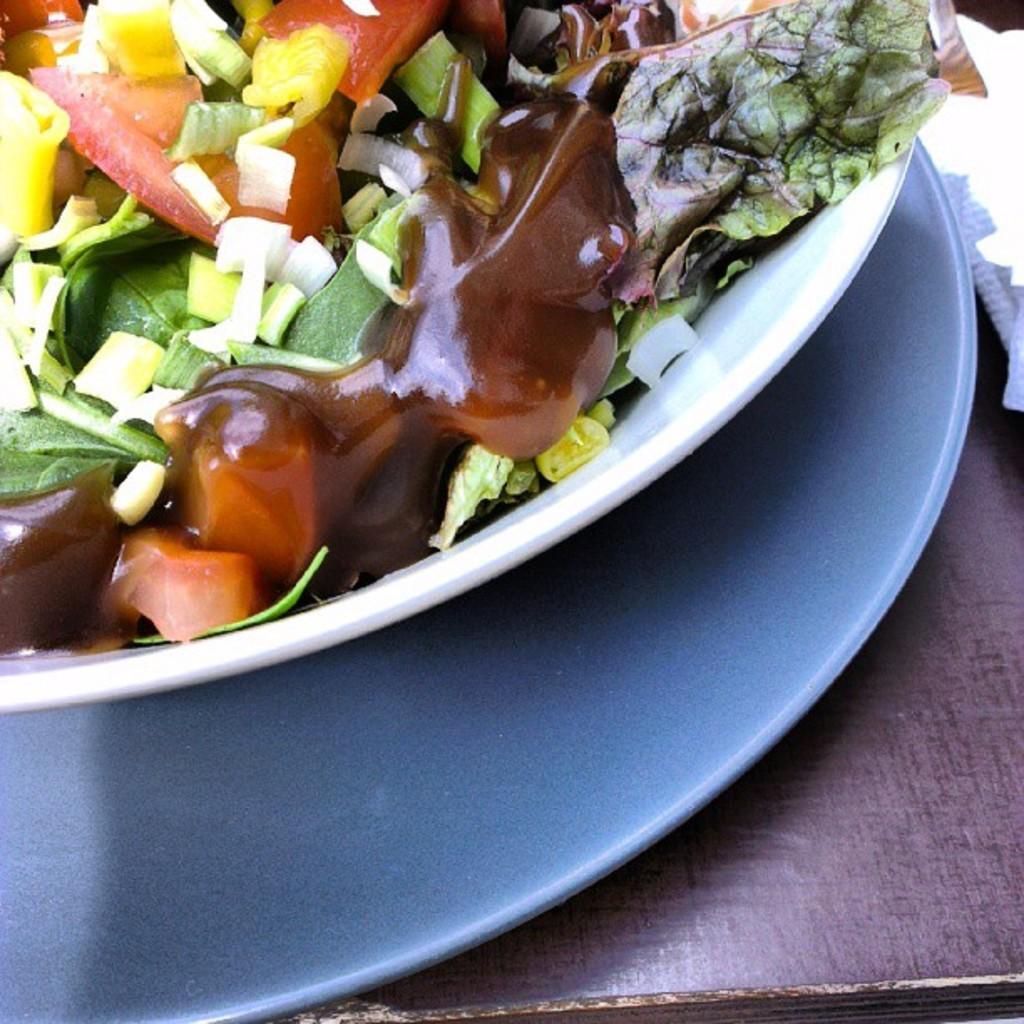In one or two sentences, can you explain what this image depicts? On the top left, there are vegetable pieces and a soup in a white color bowl which is placed on a plate. This plate is on a wooden table, on which there is a white color paper. 